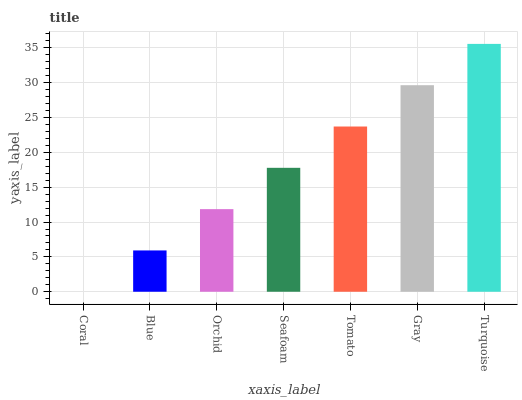Is Coral the minimum?
Answer yes or no. Yes. Is Turquoise the maximum?
Answer yes or no. Yes. Is Blue the minimum?
Answer yes or no. No. Is Blue the maximum?
Answer yes or no. No. Is Blue greater than Coral?
Answer yes or no. Yes. Is Coral less than Blue?
Answer yes or no. Yes. Is Coral greater than Blue?
Answer yes or no. No. Is Blue less than Coral?
Answer yes or no. No. Is Seafoam the high median?
Answer yes or no. Yes. Is Seafoam the low median?
Answer yes or no. Yes. Is Orchid the high median?
Answer yes or no. No. Is Coral the low median?
Answer yes or no. No. 